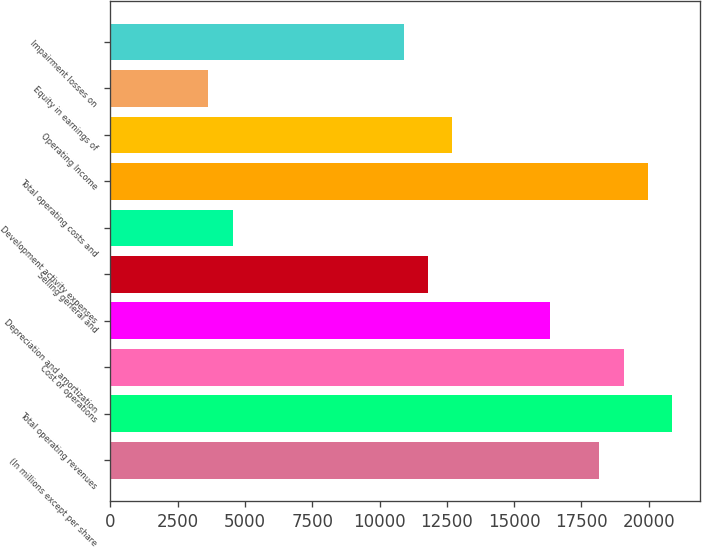<chart> <loc_0><loc_0><loc_500><loc_500><bar_chart><fcel>(In millions except per share<fcel>Total operating revenues<fcel>Cost of operations<fcel>Depreciation and amortization<fcel>Selling general and<fcel>Development activity expenses<fcel>Total operating costs and<fcel>Operating Income<fcel>Equity in earnings of<fcel>Impairment losses on<nl><fcel>18157.2<fcel>20880.6<fcel>19065<fcel>16341.5<fcel>11802.4<fcel>4539.88<fcel>19972.8<fcel>12710.3<fcel>3632.06<fcel>10894.6<nl></chart> 